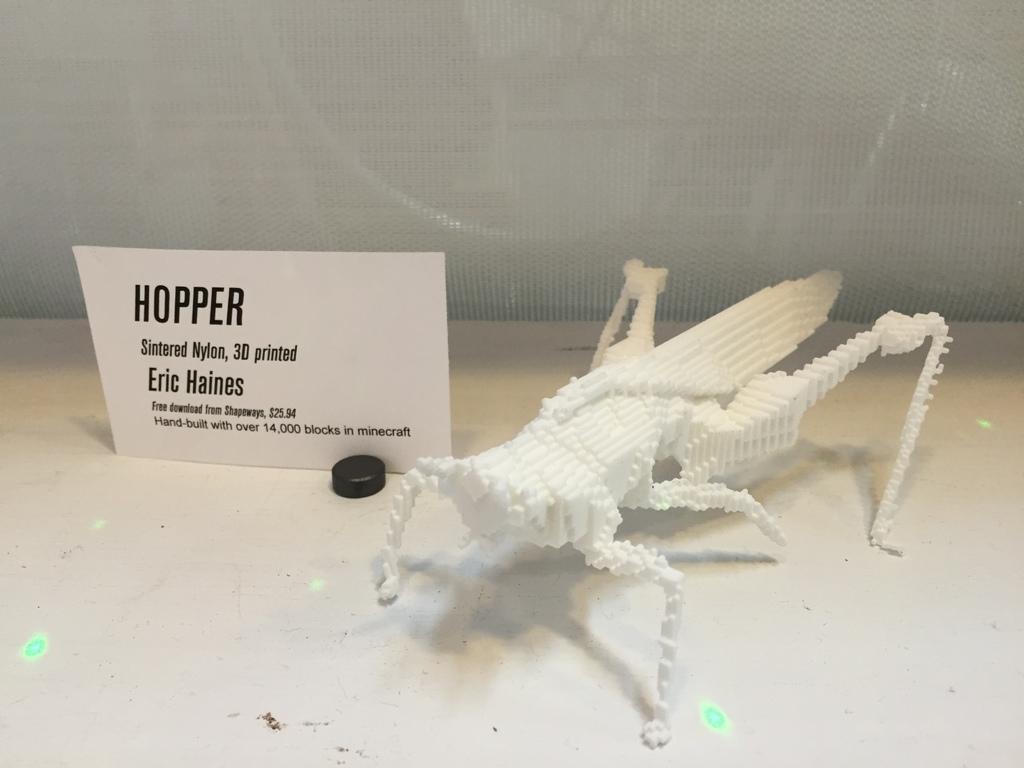Describe this image in one or two sentences. In this image there is a hopper made up of thermocool. Here there is a paper board. In the background there is a net. 